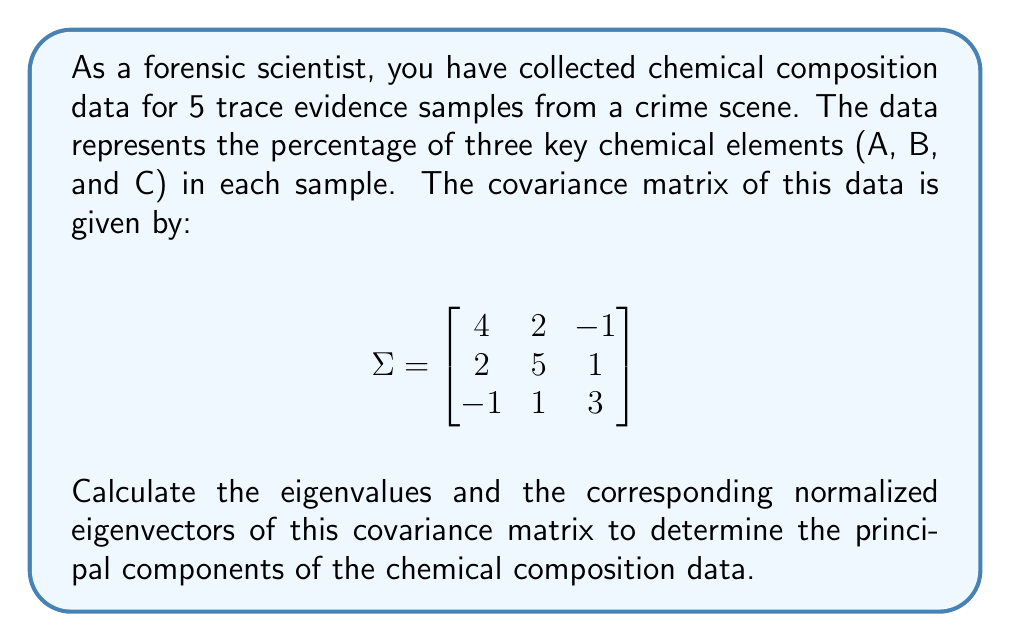Can you solve this math problem? To find the principal components, we need to calculate the eigenvalues and eigenvectors of the covariance matrix.

Step 1: Set up the characteristic equation
$$ \det(\Sigma - \lambda I) = 0 $$

Step 2: Expand the determinant
$$ \begin{vmatrix}
4-\lambda & 2 & -1 \\
2 & 5-\lambda & 1 \\
-1 & 1 & 3-\lambda
\end{vmatrix} = 0 $$

Step 3: Solve the characteristic equation
$$(4-\lambda)(5-\lambda)(3-\lambda) + 2(-1) + (-1)(2)(1) - (4-\lambda)(1)(1) - (5-\lambda)(-1)(-1) - (3-\lambda)(2)(2) = 0$$
$$-\lambda^3 + 12\lambda^2 - 41\lambda + 42 = 0$$

Step 4: Find the roots of the cubic equation (eigenvalues)
Using a cubic equation solver or numerical methods, we get:
$$\lambda_1 \approx 7.54, \lambda_2 \approx 3.17, \lambda_3 \approx 1.29$$

Step 5: Find the eigenvectors for each eigenvalue
For each $\lambda_i$, solve $(\Sigma - \lambda_i I)\vec{v} = \vec{0}$

For $\lambda_1 \approx 7.54$:
$$\vec{v}_1 \approx (0.5657, 0.7781, 0.2737)$$

For $\lambda_2 \approx 3.17$:
$$\vec{v}_2 \approx (-0.3197, 0.0741, 0.9446)$$

For $\lambda_3 \approx 1.29$:
$$\vec{v}_3 \approx (0.7602, -0.6237, 0.1826)$$

The principal components are these eigenvectors, ordered by decreasing eigenvalues.
Answer: Principal components (normalized eigenvectors):
1. $(0.5657, 0.7781, 0.2737)$
2. $(-0.3197, 0.0741, 0.9446)$
3. $(0.7602, -0.6237, 0.1826)$ 